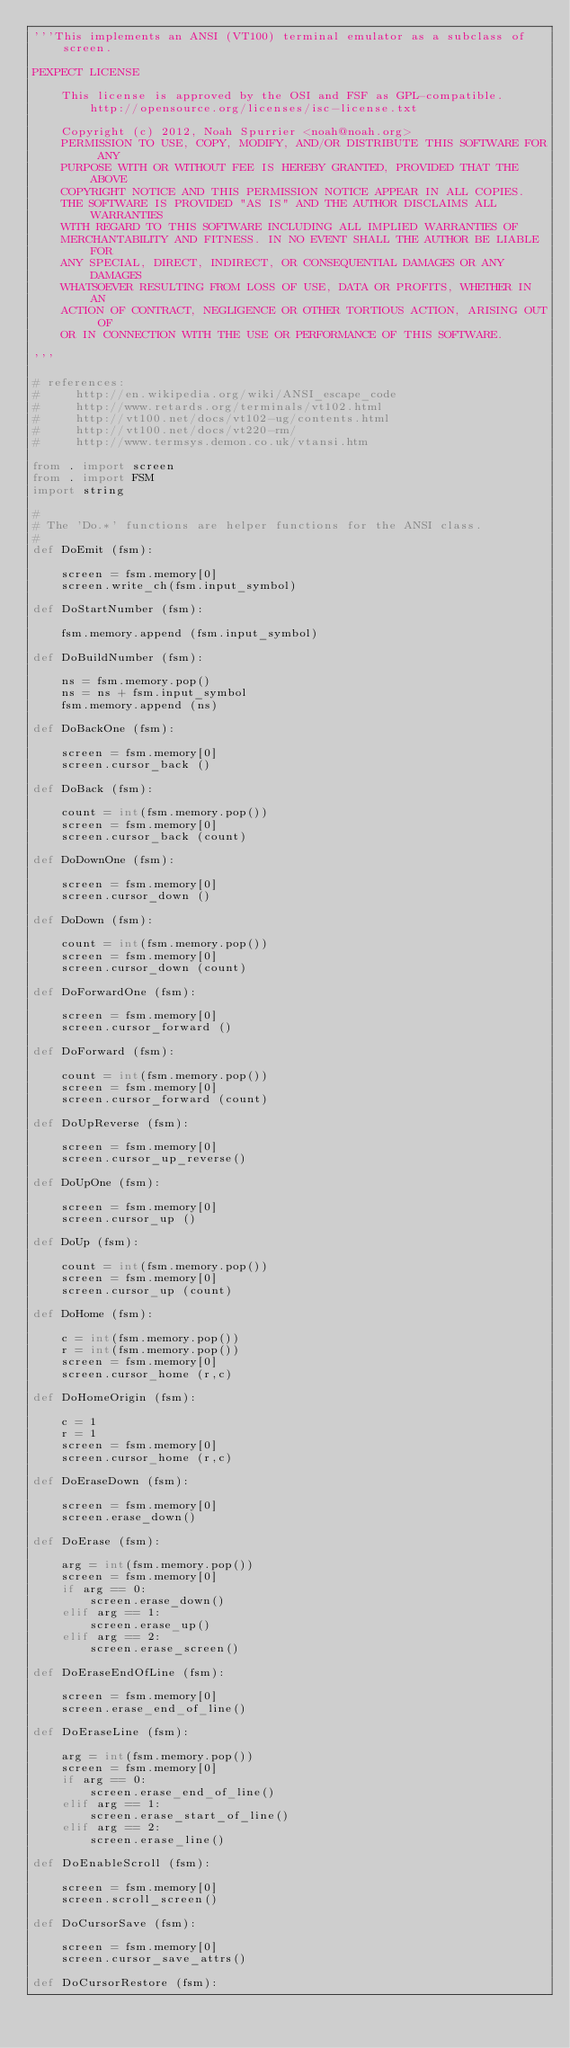<code> <loc_0><loc_0><loc_500><loc_500><_Python_>'''This implements an ANSI (VT100) terminal emulator as a subclass of screen.

PEXPECT LICENSE

    This license is approved by the OSI and FSF as GPL-compatible.
        http://opensource.org/licenses/isc-license.txt

    Copyright (c) 2012, Noah Spurrier <noah@noah.org>
    PERMISSION TO USE, COPY, MODIFY, AND/OR DISTRIBUTE THIS SOFTWARE FOR ANY
    PURPOSE WITH OR WITHOUT FEE IS HEREBY GRANTED, PROVIDED THAT THE ABOVE
    COPYRIGHT NOTICE AND THIS PERMISSION NOTICE APPEAR IN ALL COPIES.
    THE SOFTWARE IS PROVIDED "AS IS" AND THE AUTHOR DISCLAIMS ALL WARRANTIES
    WITH REGARD TO THIS SOFTWARE INCLUDING ALL IMPLIED WARRANTIES OF
    MERCHANTABILITY AND FITNESS. IN NO EVENT SHALL THE AUTHOR BE LIABLE FOR
    ANY SPECIAL, DIRECT, INDIRECT, OR CONSEQUENTIAL DAMAGES OR ANY DAMAGES
    WHATSOEVER RESULTING FROM LOSS OF USE, DATA OR PROFITS, WHETHER IN AN
    ACTION OF CONTRACT, NEGLIGENCE OR OTHER TORTIOUS ACTION, ARISING OUT OF
    OR IN CONNECTION WITH THE USE OR PERFORMANCE OF THIS SOFTWARE.

'''

# references:
#     http://en.wikipedia.org/wiki/ANSI_escape_code
#     http://www.retards.org/terminals/vt102.html
#     http://vt100.net/docs/vt102-ug/contents.html
#     http://vt100.net/docs/vt220-rm/
#     http://www.termsys.demon.co.uk/vtansi.htm

from . import screen
from . import FSM
import string

#
# The 'Do.*' functions are helper functions for the ANSI class.
#
def DoEmit (fsm):

    screen = fsm.memory[0]
    screen.write_ch(fsm.input_symbol)

def DoStartNumber (fsm):

    fsm.memory.append (fsm.input_symbol)

def DoBuildNumber (fsm):

    ns = fsm.memory.pop()
    ns = ns + fsm.input_symbol
    fsm.memory.append (ns)

def DoBackOne (fsm):

    screen = fsm.memory[0]
    screen.cursor_back ()

def DoBack (fsm):

    count = int(fsm.memory.pop())
    screen = fsm.memory[0]
    screen.cursor_back (count)

def DoDownOne (fsm):

    screen = fsm.memory[0]
    screen.cursor_down ()

def DoDown (fsm):

    count = int(fsm.memory.pop())
    screen = fsm.memory[0]
    screen.cursor_down (count)

def DoForwardOne (fsm):

    screen = fsm.memory[0]
    screen.cursor_forward ()

def DoForward (fsm):

    count = int(fsm.memory.pop())
    screen = fsm.memory[0]
    screen.cursor_forward (count)

def DoUpReverse (fsm):

    screen = fsm.memory[0]
    screen.cursor_up_reverse()

def DoUpOne (fsm):

    screen = fsm.memory[0]
    screen.cursor_up ()

def DoUp (fsm):

    count = int(fsm.memory.pop())
    screen = fsm.memory[0]
    screen.cursor_up (count)

def DoHome (fsm):

    c = int(fsm.memory.pop())
    r = int(fsm.memory.pop())
    screen = fsm.memory[0]
    screen.cursor_home (r,c)

def DoHomeOrigin (fsm):

    c = 1
    r = 1
    screen = fsm.memory[0]
    screen.cursor_home (r,c)

def DoEraseDown (fsm):

    screen = fsm.memory[0]
    screen.erase_down()

def DoErase (fsm):

    arg = int(fsm.memory.pop())
    screen = fsm.memory[0]
    if arg == 0:
        screen.erase_down()
    elif arg == 1:
        screen.erase_up()
    elif arg == 2:
        screen.erase_screen()

def DoEraseEndOfLine (fsm):

    screen = fsm.memory[0]
    screen.erase_end_of_line()

def DoEraseLine (fsm):

    arg = int(fsm.memory.pop())
    screen = fsm.memory[0]
    if arg == 0:
        screen.erase_end_of_line()
    elif arg == 1:
        screen.erase_start_of_line()
    elif arg == 2:
        screen.erase_line()

def DoEnableScroll (fsm):

    screen = fsm.memory[0]
    screen.scroll_screen()

def DoCursorSave (fsm):

    screen = fsm.memory[0]
    screen.cursor_save_attrs()

def DoCursorRestore (fsm):
</code> 